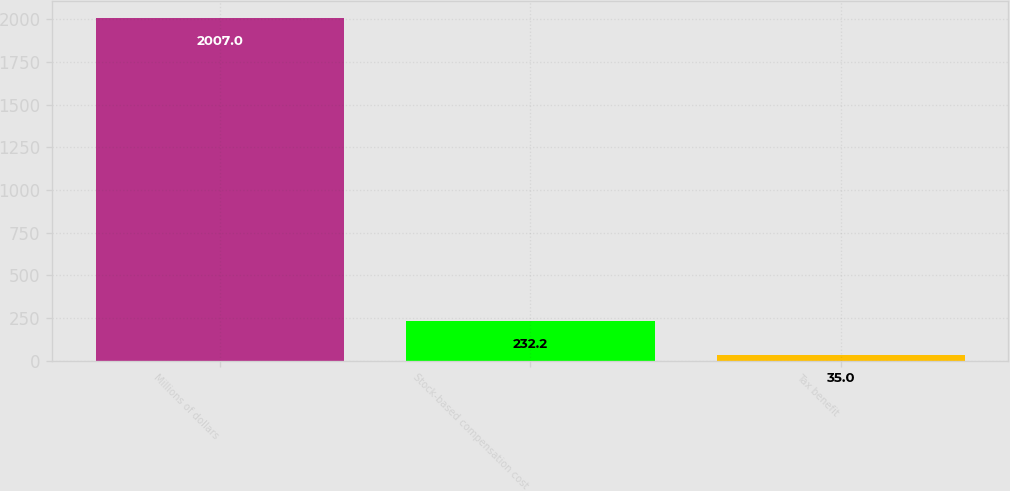Convert chart to OTSL. <chart><loc_0><loc_0><loc_500><loc_500><bar_chart><fcel>Millions of dollars<fcel>Stock-based compensation cost<fcel>Tax benefit<nl><fcel>2007<fcel>232.2<fcel>35<nl></chart> 